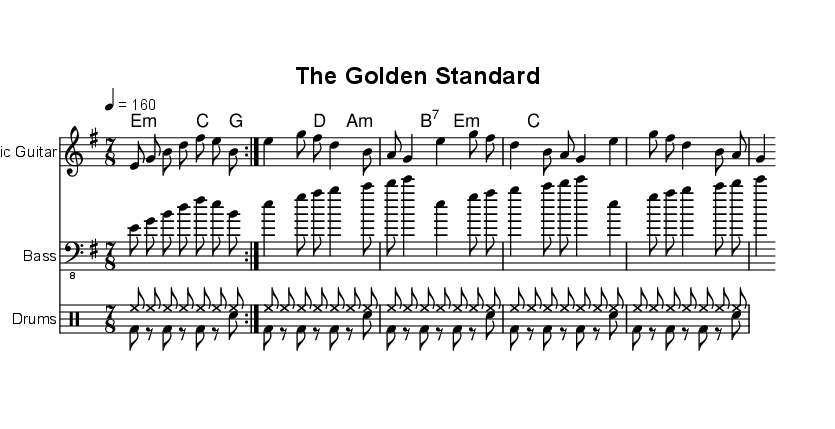What is the key signature of this music? The key signature is E minor, which has one sharp (F#). This can be determined from the key signature indicated at the beginning of the staff, which shows one sharp, characteristic of E minor.
Answer: E minor What is the time signature of the piece? The time signature is 7/8, as indicated at the start of the music. This means there are 7 eighth notes in each measure, distinguishing it from more common time signatures.
Answer: 7/8 What is the tempo marking of this piece? The tempo marking is quarter note equals 160 bpm. This can be found at the beginning of the score, indicating a lively, brisk speed for the piece.
Answer: 160 How many measures are there in the electric guitar part? The electric guitar part contains 16 measures, which can be counted by observing the repeating sections and accounting for the volta markings that indicate a repeat of the measures.
Answer: 16 What type of scale is prominently featured based on the notes in the electric guitar? The prominent scale is E minor pentatonic, which can be identified by the specific notes used (E, G, B, D, and F#) in the melody that fit within the E minor context.
Answer: E minor pentatonic Which instruments are used in this piece? The piece features electric guitar, bass guitar, and drums, which are explicitly stated in the staff names at the beginning of each respective part.
Answer: Electric guitar, bass, drums What thematic concept does the lyrics of the song explore? The lyrics explore the theme of monetary evolution, referencing the transition from gold coins to digital currencies and the historical role of bankers, which is clearly articulated in the lyrical text.
Answer: Monetary evolution 